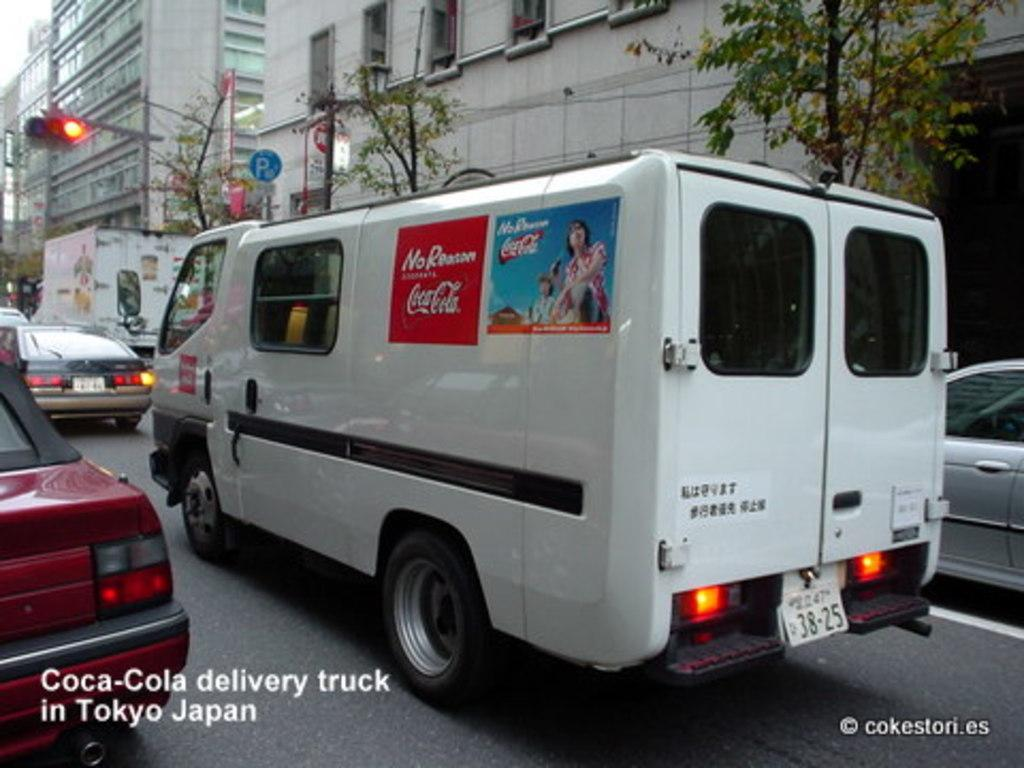<image>
Render a clear and concise summary of the photo. a coca cola delivery truck that has signs on it 